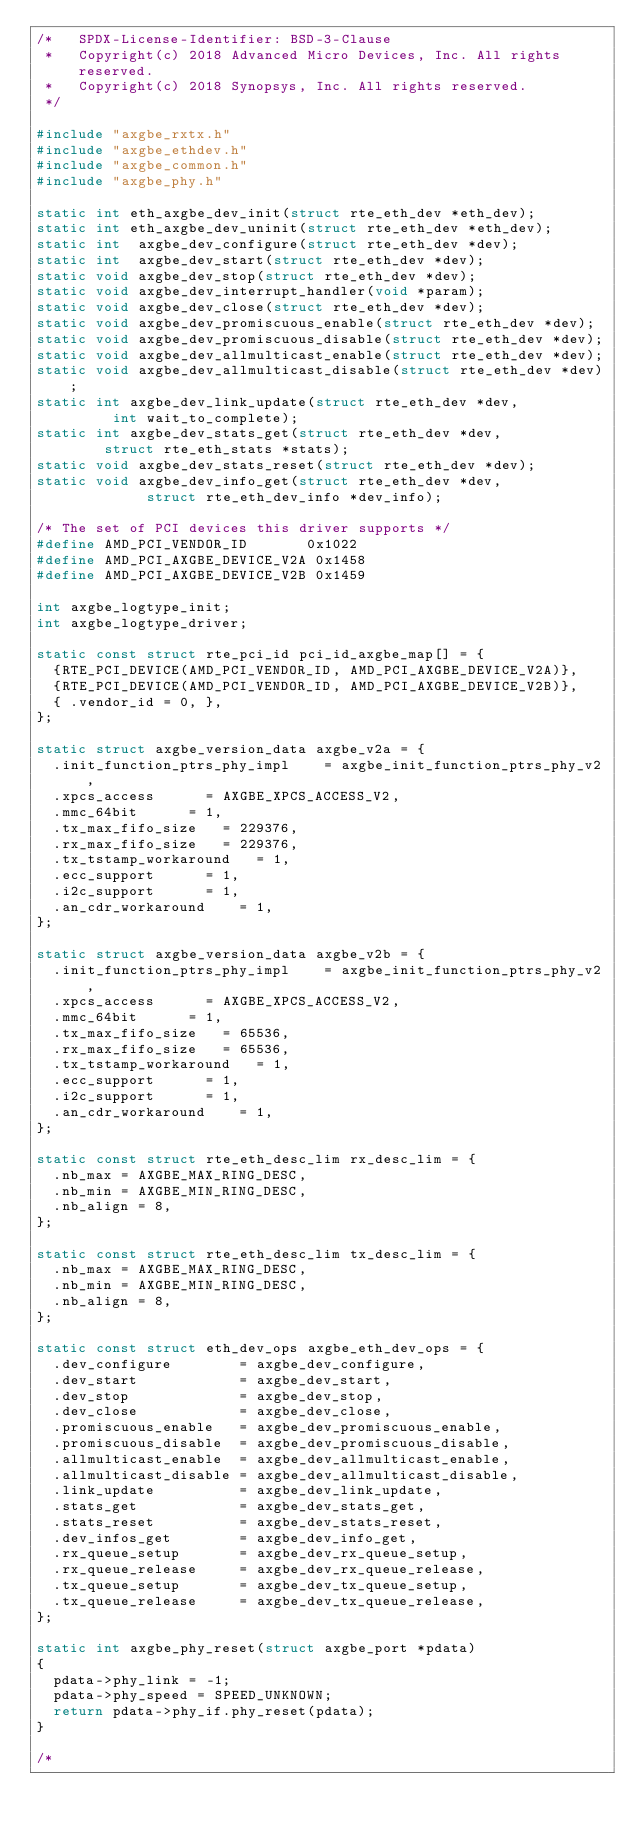Convert code to text. <code><loc_0><loc_0><loc_500><loc_500><_C_>/*   SPDX-License-Identifier: BSD-3-Clause
 *   Copyright(c) 2018 Advanced Micro Devices, Inc. All rights reserved.
 *   Copyright(c) 2018 Synopsys, Inc. All rights reserved.
 */

#include "axgbe_rxtx.h"
#include "axgbe_ethdev.h"
#include "axgbe_common.h"
#include "axgbe_phy.h"

static int eth_axgbe_dev_init(struct rte_eth_dev *eth_dev);
static int eth_axgbe_dev_uninit(struct rte_eth_dev *eth_dev);
static int  axgbe_dev_configure(struct rte_eth_dev *dev);
static int  axgbe_dev_start(struct rte_eth_dev *dev);
static void axgbe_dev_stop(struct rte_eth_dev *dev);
static void axgbe_dev_interrupt_handler(void *param);
static void axgbe_dev_close(struct rte_eth_dev *dev);
static void axgbe_dev_promiscuous_enable(struct rte_eth_dev *dev);
static void axgbe_dev_promiscuous_disable(struct rte_eth_dev *dev);
static void axgbe_dev_allmulticast_enable(struct rte_eth_dev *dev);
static void axgbe_dev_allmulticast_disable(struct rte_eth_dev *dev);
static int axgbe_dev_link_update(struct rte_eth_dev *dev,
				 int wait_to_complete);
static int axgbe_dev_stats_get(struct rte_eth_dev *dev,
				struct rte_eth_stats *stats);
static void axgbe_dev_stats_reset(struct rte_eth_dev *dev);
static void axgbe_dev_info_get(struct rte_eth_dev *dev,
			       struct rte_eth_dev_info *dev_info);

/* The set of PCI devices this driver supports */
#define AMD_PCI_VENDOR_ID       0x1022
#define AMD_PCI_AXGBE_DEVICE_V2A 0x1458
#define AMD_PCI_AXGBE_DEVICE_V2B 0x1459

int axgbe_logtype_init;
int axgbe_logtype_driver;

static const struct rte_pci_id pci_id_axgbe_map[] = {
	{RTE_PCI_DEVICE(AMD_PCI_VENDOR_ID, AMD_PCI_AXGBE_DEVICE_V2A)},
	{RTE_PCI_DEVICE(AMD_PCI_VENDOR_ID, AMD_PCI_AXGBE_DEVICE_V2B)},
	{ .vendor_id = 0, },
};

static struct axgbe_version_data axgbe_v2a = {
	.init_function_ptrs_phy_impl    = axgbe_init_function_ptrs_phy_v2,
	.xpcs_access			= AXGBE_XPCS_ACCESS_V2,
	.mmc_64bit			= 1,
	.tx_max_fifo_size		= 229376,
	.rx_max_fifo_size		= 229376,
	.tx_tstamp_workaround		= 1,
	.ecc_support			= 1,
	.i2c_support			= 1,
	.an_cdr_workaround		= 1,
};

static struct axgbe_version_data axgbe_v2b = {
	.init_function_ptrs_phy_impl    = axgbe_init_function_ptrs_phy_v2,
	.xpcs_access			= AXGBE_XPCS_ACCESS_V2,
	.mmc_64bit			= 1,
	.tx_max_fifo_size		= 65536,
	.rx_max_fifo_size		= 65536,
	.tx_tstamp_workaround		= 1,
	.ecc_support			= 1,
	.i2c_support			= 1,
	.an_cdr_workaround		= 1,
};

static const struct rte_eth_desc_lim rx_desc_lim = {
	.nb_max = AXGBE_MAX_RING_DESC,
	.nb_min = AXGBE_MIN_RING_DESC,
	.nb_align = 8,
};

static const struct rte_eth_desc_lim tx_desc_lim = {
	.nb_max = AXGBE_MAX_RING_DESC,
	.nb_min = AXGBE_MIN_RING_DESC,
	.nb_align = 8,
};

static const struct eth_dev_ops axgbe_eth_dev_ops = {
	.dev_configure        = axgbe_dev_configure,
	.dev_start            = axgbe_dev_start,
	.dev_stop             = axgbe_dev_stop,
	.dev_close            = axgbe_dev_close,
	.promiscuous_enable   = axgbe_dev_promiscuous_enable,
	.promiscuous_disable  = axgbe_dev_promiscuous_disable,
	.allmulticast_enable  = axgbe_dev_allmulticast_enable,
	.allmulticast_disable = axgbe_dev_allmulticast_disable,
	.link_update          = axgbe_dev_link_update,
	.stats_get            = axgbe_dev_stats_get,
	.stats_reset          = axgbe_dev_stats_reset,
	.dev_infos_get        = axgbe_dev_info_get,
	.rx_queue_setup       = axgbe_dev_rx_queue_setup,
	.rx_queue_release     = axgbe_dev_rx_queue_release,
	.tx_queue_setup       = axgbe_dev_tx_queue_setup,
	.tx_queue_release     = axgbe_dev_tx_queue_release,
};

static int axgbe_phy_reset(struct axgbe_port *pdata)
{
	pdata->phy_link = -1;
	pdata->phy_speed = SPEED_UNKNOWN;
	return pdata->phy_if.phy_reset(pdata);
}

/*</code> 